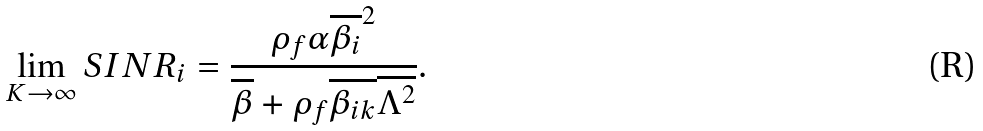<formula> <loc_0><loc_0><loc_500><loc_500>\lim _ { K \rightarrow \infty } S I N R _ { i } = \frac { \rho _ { f } \alpha \overline { \beta _ { i } } ^ { 2 } } { \overline { \beta } + \rho _ { f } \overline { \beta _ { i k } } \overline { \Lambda ^ { 2 } } } .</formula> 